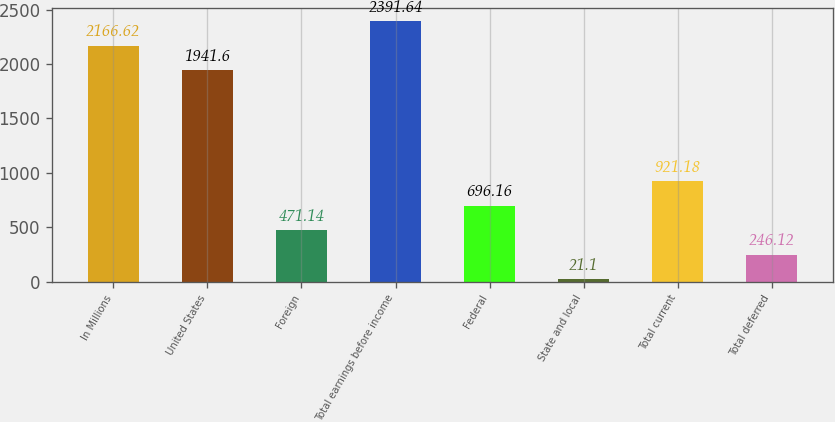Convert chart. <chart><loc_0><loc_0><loc_500><loc_500><bar_chart><fcel>In Millions<fcel>United States<fcel>Foreign<fcel>Total earnings before income<fcel>Federal<fcel>State and local<fcel>Total current<fcel>Total deferred<nl><fcel>2166.62<fcel>1941.6<fcel>471.14<fcel>2391.64<fcel>696.16<fcel>21.1<fcel>921.18<fcel>246.12<nl></chart> 